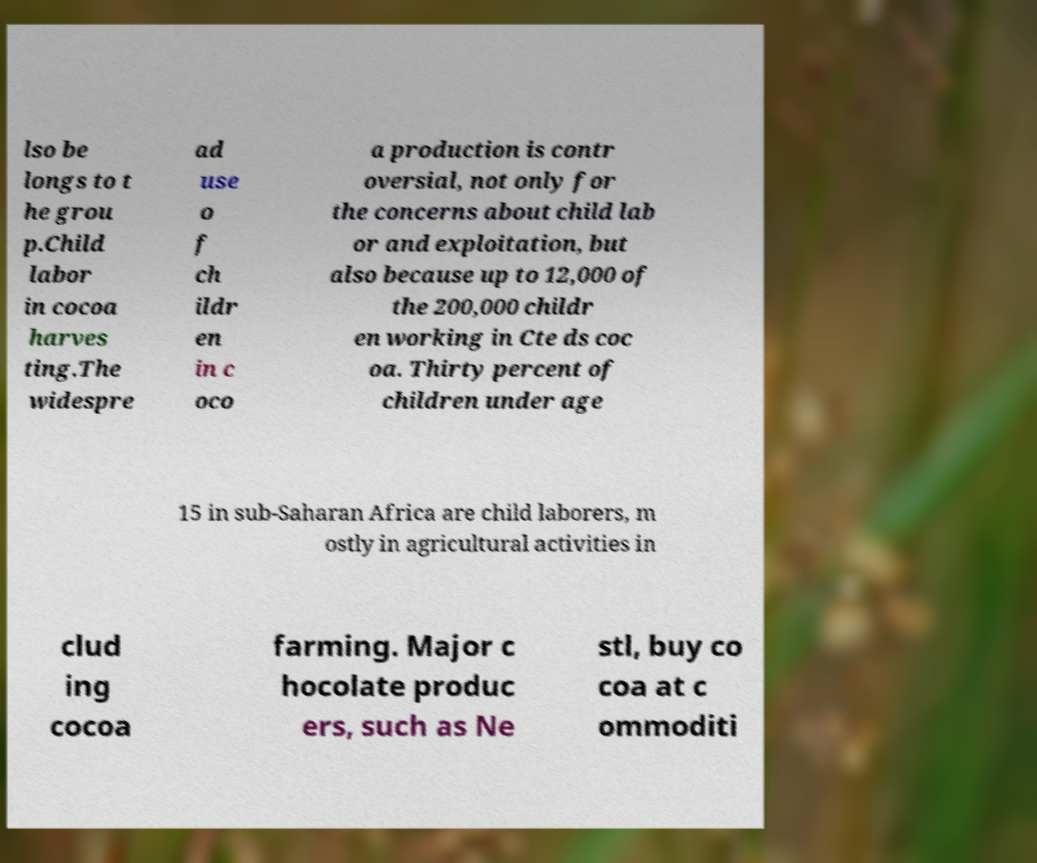There's text embedded in this image that I need extracted. Can you transcribe it verbatim? lso be longs to t he grou p.Child labor in cocoa harves ting.The widespre ad use o f ch ildr en in c oco a production is contr oversial, not only for the concerns about child lab or and exploitation, but also because up to 12,000 of the 200,000 childr en working in Cte ds coc oa. Thirty percent of children under age 15 in sub-Saharan Africa are child laborers, m ostly in agricultural activities in clud ing cocoa farming. Major c hocolate produc ers, such as Ne stl, buy co coa at c ommoditi 